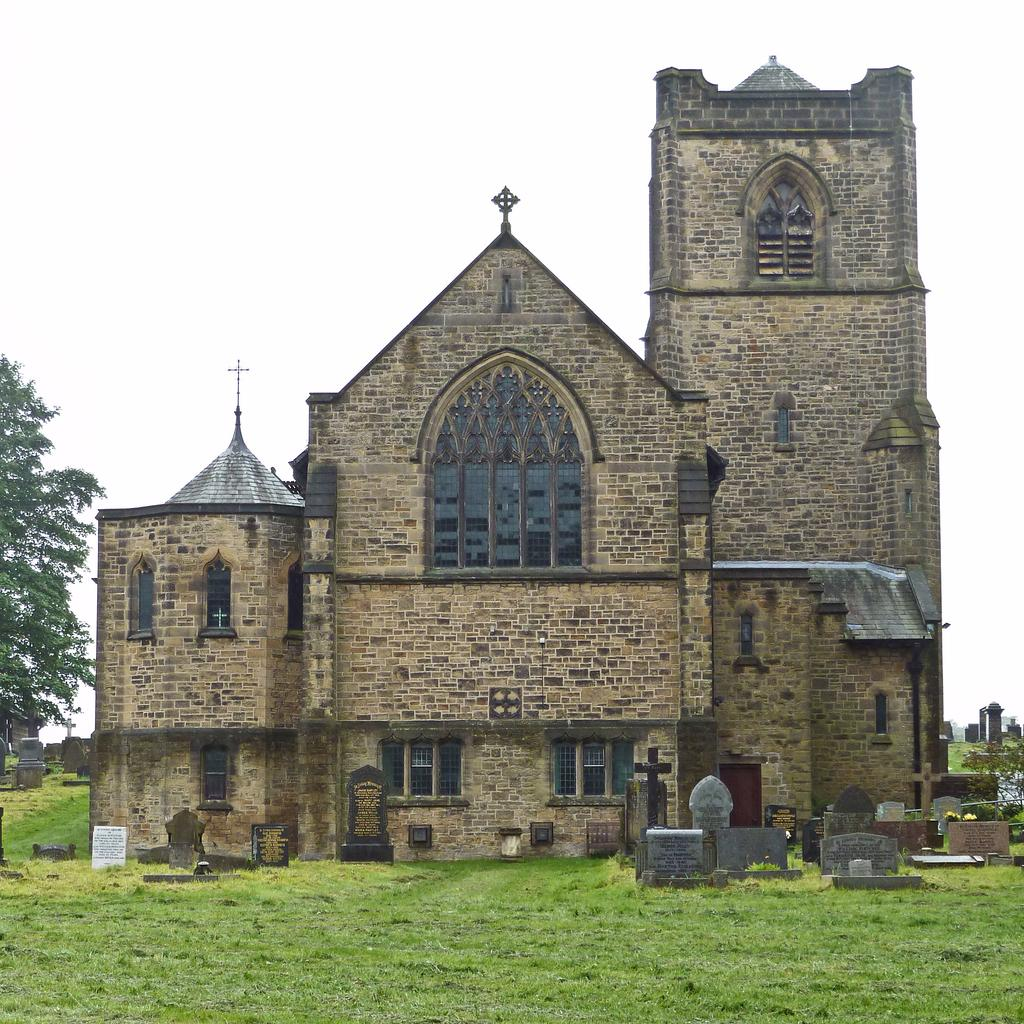Where was the image taken from? The image was taken from the outside of a building. What can be seen on the left side of the image? There are trees on the left side of the image. What is visible at the top of the image? The sky is visible at the top of the image. What can be seen at the bottom of the image? There are planets and grass visible at the bottom of the image. What type of teaching is happening in the image? There is no teaching activity visible in the image. 